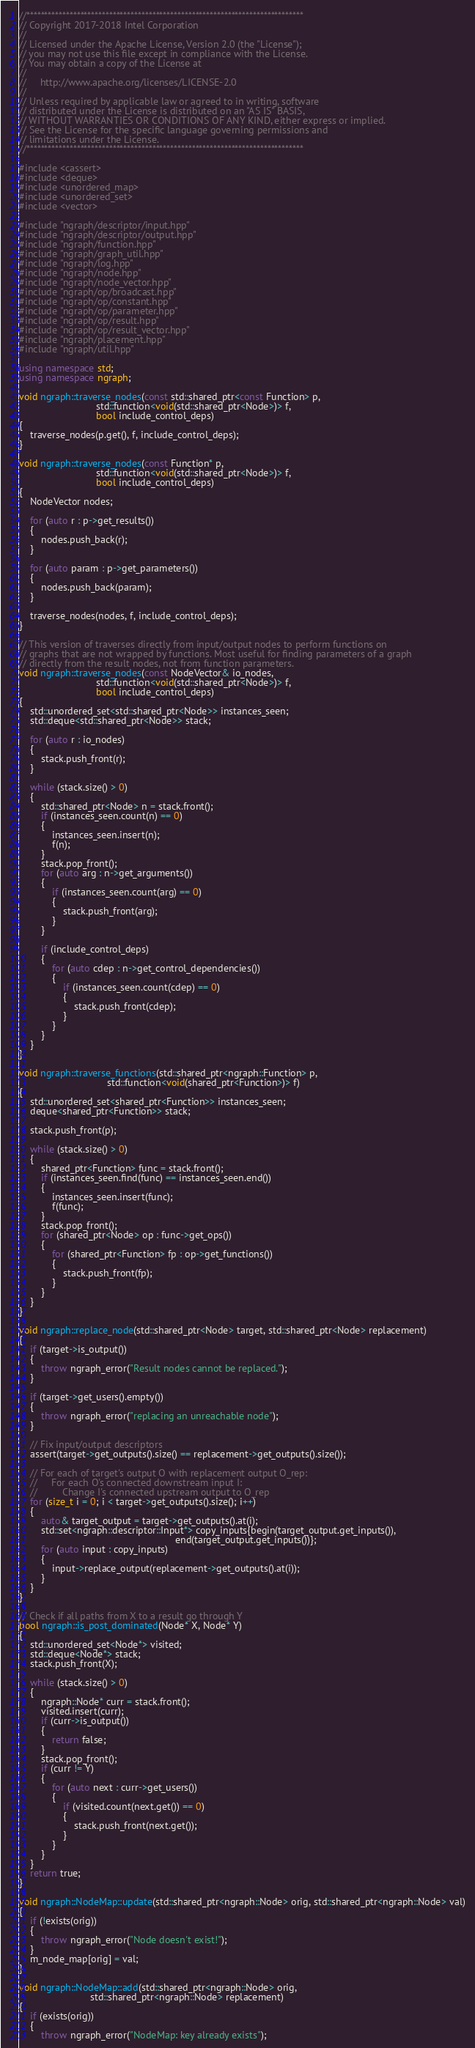Convert code to text. <code><loc_0><loc_0><loc_500><loc_500><_C++_>//*****************************************************************************
// Copyright 2017-2018 Intel Corporation
//
// Licensed under the Apache License, Version 2.0 (the "License");
// you may not use this file except in compliance with the License.
// You may obtain a copy of the License at
//
//     http://www.apache.org/licenses/LICENSE-2.0
//
// Unless required by applicable law or agreed to in writing, software
// distributed under the License is distributed on an "AS IS" BASIS,
// WITHOUT WARRANTIES OR CONDITIONS OF ANY KIND, either express or implied.
// See the License for the specific language governing permissions and
// limitations under the License.
//*****************************************************************************

#include <cassert>
#include <deque>
#include <unordered_map>
#include <unordered_set>
#include <vector>

#include "ngraph/descriptor/input.hpp"
#include "ngraph/descriptor/output.hpp"
#include "ngraph/function.hpp"
#include "ngraph/graph_util.hpp"
#include "ngraph/log.hpp"
#include "ngraph/node.hpp"
#include "ngraph/node_vector.hpp"
#include "ngraph/op/broadcast.hpp"
#include "ngraph/op/constant.hpp"
#include "ngraph/op/parameter.hpp"
#include "ngraph/op/result.hpp"
#include "ngraph/op/result_vector.hpp"
#include "ngraph/placement.hpp"
#include "ngraph/util.hpp"

using namespace std;
using namespace ngraph;

void ngraph::traverse_nodes(const std::shared_ptr<const Function> p,
                            std::function<void(std::shared_ptr<Node>)> f,
                            bool include_control_deps)
{
    traverse_nodes(p.get(), f, include_control_deps);
}

void ngraph::traverse_nodes(const Function* p,
                            std::function<void(std::shared_ptr<Node>)> f,
                            bool include_control_deps)
{
    NodeVector nodes;

    for (auto r : p->get_results())
    {
        nodes.push_back(r);
    }

    for (auto param : p->get_parameters())
    {
        nodes.push_back(param);
    }

    traverse_nodes(nodes, f, include_control_deps);
}

// This version of traverses directly from input/output nodes to perform functions on
// graphs that are not wrapped by functions. Most useful for finding parameters of a graph
// directly from the result nodes, not from function parameters.
void ngraph::traverse_nodes(const NodeVector& io_nodes,
                            std::function<void(std::shared_ptr<Node>)> f,
                            bool include_control_deps)
{
    std::unordered_set<std::shared_ptr<Node>> instances_seen;
    std::deque<std::shared_ptr<Node>> stack;

    for (auto r : io_nodes)
    {
        stack.push_front(r);
    }

    while (stack.size() > 0)
    {
        std::shared_ptr<Node> n = stack.front();
        if (instances_seen.count(n) == 0)
        {
            instances_seen.insert(n);
            f(n);
        }
        stack.pop_front();
        for (auto arg : n->get_arguments())
        {
            if (instances_seen.count(arg) == 0)
            {
                stack.push_front(arg);
            }
        }

        if (include_control_deps)
        {
            for (auto cdep : n->get_control_dependencies())
            {
                if (instances_seen.count(cdep) == 0)
                {
                    stack.push_front(cdep);
                }
            }
        }
    }
}

void ngraph::traverse_functions(std::shared_ptr<ngraph::Function> p,
                                std::function<void(shared_ptr<Function>)> f)
{
    std::unordered_set<shared_ptr<Function>> instances_seen;
    deque<shared_ptr<Function>> stack;

    stack.push_front(p);

    while (stack.size() > 0)
    {
        shared_ptr<Function> func = stack.front();
        if (instances_seen.find(func) == instances_seen.end())
        {
            instances_seen.insert(func);
            f(func);
        }
        stack.pop_front();
        for (shared_ptr<Node> op : func->get_ops())
        {
            for (shared_ptr<Function> fp : op->get_functions())
            {
                stack.push_front(fp);
            }
        }
    }
}

void ngraph::replace_node(std::shared_ptr<Node> target, std::shared_ptr<Node> replacement)
{
    if (target->is_output())
    {
        throw ngraph_error("Result nodes cannot be replaced.");
    }

    if (target->get_users().empty())
    {
        throw ngraph_error("replacing an unreachable node");
    }

    // Fix input/output descriptors
    assert(target->get_outputs().size() == replacement->get_outputs().size());

    // For each of target's output O with replacement output O_rep:
    //     For each O's connected downstream input I:
    //         Change I's connected upstream output to O_rep
    for (size_t i = 0; i < target->get_outputs().size(); i++)
    {
        auto& target_output = target->get_outputs().at(i);
        std::set<ngraph::descriptor::Input*> copy_inputs{begin(target_output.get_inputs()),
                                                         end(target_output.get_inputs())};
        for (auto input : copy_inputs)
        {
            input->replace_output(replacement->get_outputs().at(i));
        }
    }
}

// Check if all paths from X to a result go through Y
bool ngraph::is_post_dominated(Node* X, Node* Y)
{
    std::unordered_set<Node*> visited;
    std::deque<Node*> stack;
    stack.push_front(X);

    while (stack.size() > 0)
    {
        ngraph::Node* curr = stack.front();
        visited.insert(curr);
        if (curr->is_output())
        {
            return false;
        }
        stack.pop_front();
        if (curr != Y)
        {
            for (auto next : curr->get_users())
            {
                if (visited.count(next.get()) == 0)
                {
                    stack.push_front(next.get());
                }
            }
        }
    }
    return true;
}

void ngraph::NodeMap::update(std::shared_ptr<ngraph::Node> orig, std::shared_ptr<ngraph::Node> val)
{
    if (!exists(orig))
    {
        throw ngraph_error("Node doesn't exist!");
    }
    m_node_map[orig] = val;
}

void ngraph::NodeMap::add(std::shared_ptr<ngraph::Node> orig,
                          std::shared_ptr<ngraph::Node> replacement)
{
    if (exists(orig))
    {
        throw ngraph_error("NodeMap: key already exists");</code> 